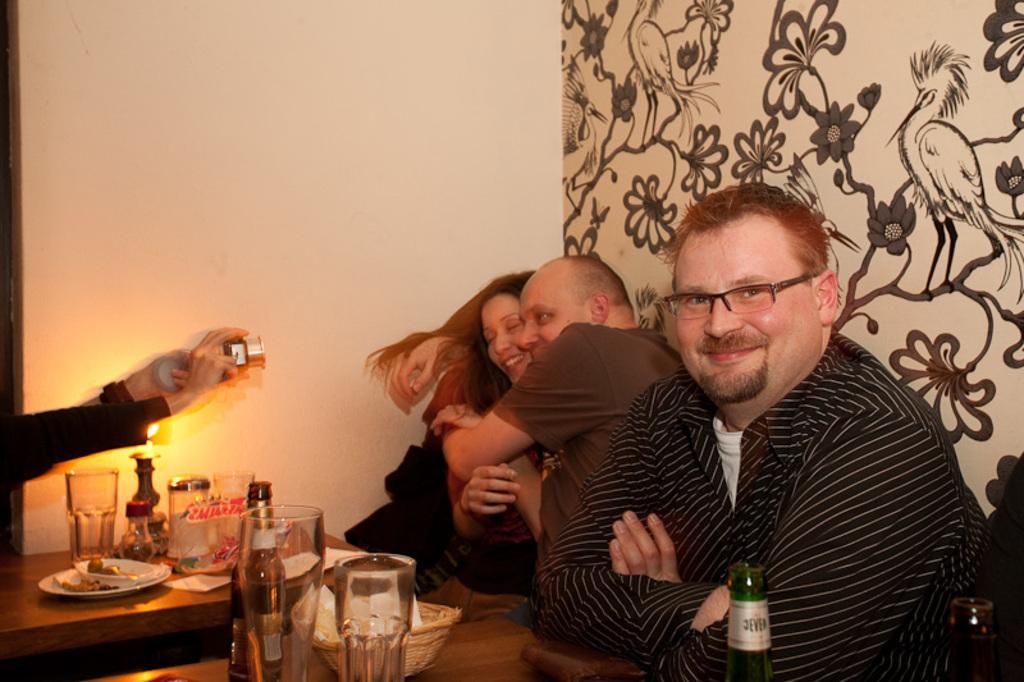Describe this image in one or two sentences. In this picture there are people sitting on the table with food items on top of it. In the background we observe two people posing for a picture and a guy is clicking them. 